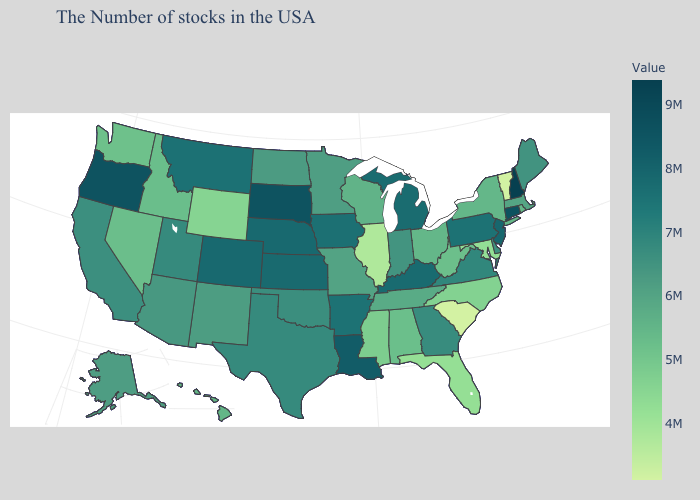Which states hav the highest value in the South?
Quick response, please. Louisiana. Which states have the lowest value in the USA?
Keep it brief. South Carolina. Does New Hampshire have the highest value in the USA?
Keep it brief. Yes. Does the map have missing data?
Be succinct. No. Which states have the lowest value in the South?
Answer briefly. South Carolina. Does Utah have a higher value than Oregon?
Answer briefly. No. Is the legend a continuous bar?
Be succinct. Yes. Does New Hampshire have the highest value in the USA?
Be succinct. Yes. 